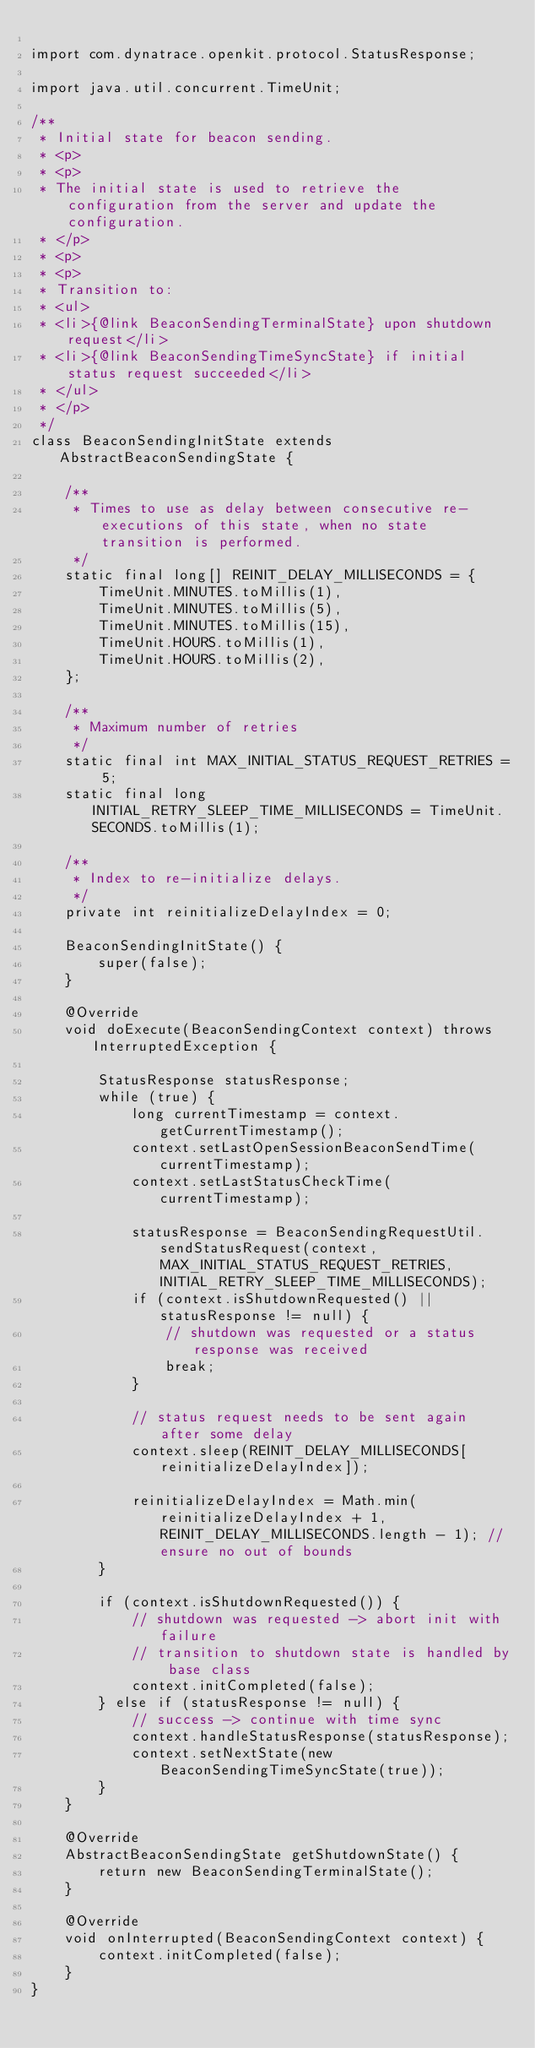Convert code to text. <code><loc_0><loc_0><loc_500><loc_500><_Java_>
import com.dynatrace.openkit.protocol.StatusResponse;

import java.util.concurrent.TimeUnit;

/**
 * Initial state for beacon sending.
 * <p>
 * <p>
 * The initial state is used to retrieve the configuration from the server and update the configuration.
 * </p>
 * <p>
 * <p>
 * Transition to:
 * <ul>
 * <li>{@link BeaconSendingTerminalState} upon shutdown request</li>
 * <li>{@link BeaconSendingTimeSyncState} if initial status request succeeded</li>
 * </ul>
 * </p>
 */
class BeaconSendingInitState extends AbstractBeaconSendingState {

    /**
     * Times to use as delay between consecutive re-executions of this state, when no state transition is performed.
     */
    static final long[] REINIT_DELAY_MILLISECONDS = {
        TimeUnit.MINUTES.toMillis(1),
        TimeUnit.MINUTES.toMillis(5),
        TimeUnit.MINUTES.toMillis(15),
        TimeUnit.HOURS.toMillis(1),
        TimeUnit.HOURS.toMillis(2),
    };

    /**
     * Maximum number of retries
     */
    static final int MAX_INITIAL_STATUS_REQUEST_RETRIES = 5;
    static final long INITIAL_RETRY_SLEEP_TIME_MILLISECONDS = TimeUnit.SECONDS.toMillis(1);

    /**
     * Index to re-initialize delays.
     */
    private int reinitializeDelayIndex = 0;

    BeaconSendingInitState() {
        super(false);
    }

    @Override
    void doExecute(BeaconSendingContext context) throws InterruptedException {

        StatusResponse statusResponse;
        while (true) {
            long currentTimestamp = context.getCurrentTimestamp();
            context.setLastOpenSessionBeaconSendTime(currentTimestamp);
            context.setLastStatusCheckTime(currentTimestamp);

            statusResponse = BeaconSendingRequestUtil.sendStatusRequest(context, MAX_INITIAL_STATUS_REQUEST_RETRIES, INITIAL_RETRY_SLEEP_TIME_MILLISECONDS);
            if (context.isShutdownRequested() || statusResponse != null) {
                // shutdown was requested or a status response was received
                break;
            }

            // status request needs to be sent again after some delay
            context.sleep(REINIT_DELAY_MILLISECONDS[reinitializeDelayIndex]);

            reinitializeDelayIndex = Math.min(reinitializeDelayIndex + 1, REINIT_DELAY_MILLISECONDS.length - 1); // ensure no out of bounds
        }

        if (context.isShutdownRequested()) {
            // shutdown was requested -> abort init with failure
            // transition to shutdown state is handled by base class
            context.initCompleted(false);
        } else if (statusResponse != null) {
            // success -> continue with time sync
            context.handleStatusResponse(statusResponse);
            context.setNextState(new BeaconSendingTimeSyncState(true));
        }
    }

    @Override
    AbstractBeaconSendingState getShutdownState() {
        return new BeaconSendingTerminalState();
    }

    @Override
    void onInterrupted(BeaconSendingContext context) {
        context.initCompleted(false);
    }
}</code> 